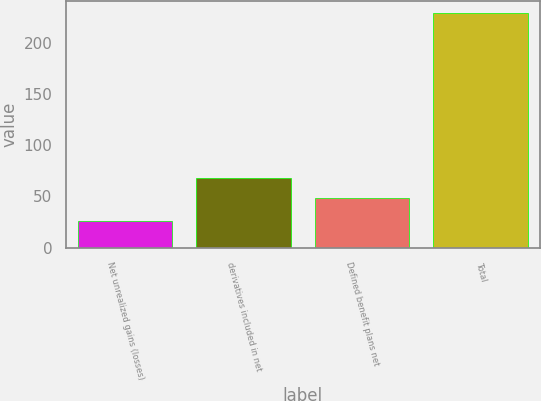Convert chart. <chart><loc_0><loc_0><loc_500><loc_500><bar_chart><fcel>Net unrealized gains (losses)<fcel>derivatives included in net<fcel>Defined benefit plans net<fcel>Total<nl><fcel>26<fcel>67.8<fcel>48<fcel>228.8<nl></chart> 